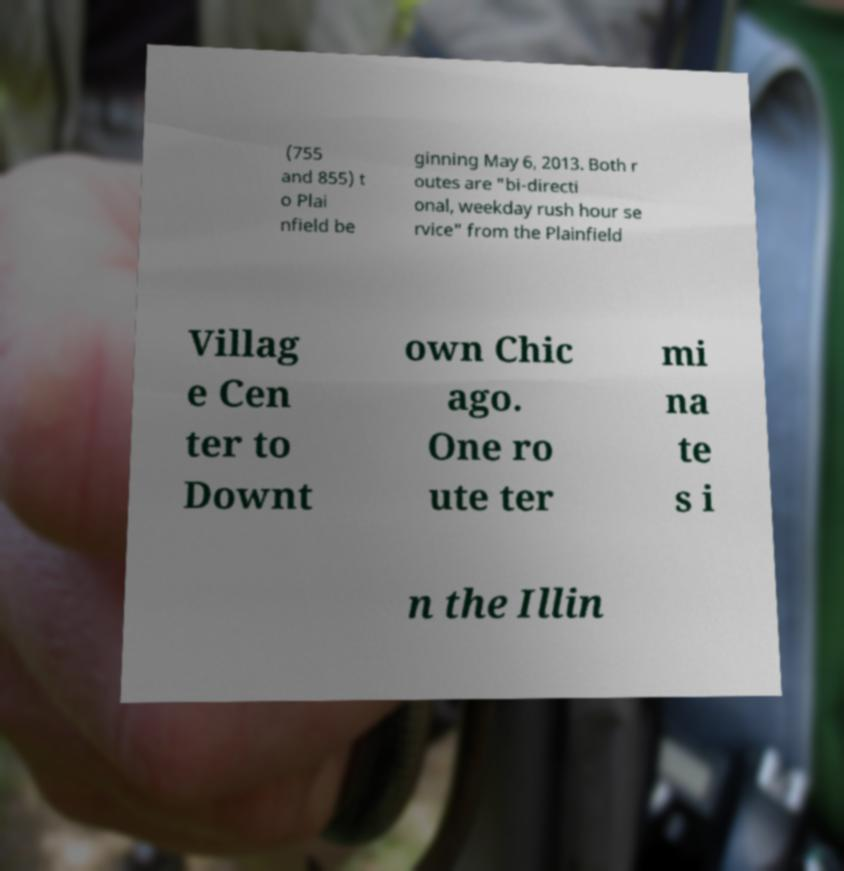Can you read and provide the text displayed in the image?This photo seems to have some interesting text. Can you extract and type it out for me? (755 and 855) t o Plai nfield be ginning May 6, 2013. Both r outes are "bi-directi onal, weekday rush hour se rvice" from the Plainfield Villag e Cen ter to Downt own Chic ago. One ro ute ter mi na te s i n the Illin 